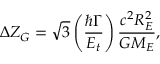<formula> <loc_0><loc_0><loc_500><loc_500>\Delta Z _ { G } = \sqrt { 3 } \left ( \frac { \hbar { \Gamma } } { E _ { t } } \right ) \frac { c ^ { 2 } R _ { E } ^ { 2 } } { G M _ { E } } ,</formula> 